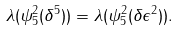<formula> <loc_0><loc_0><loc_500><loc_500>\lambda ( \psi _ { 5 } ^ { 2 } ( \delta ^ { 5 } ) ) = \lambda ( \psi _ { 5 } ^ { 2 } ( \delta \epsilon ^ { 2 } ) ) .</formula> 